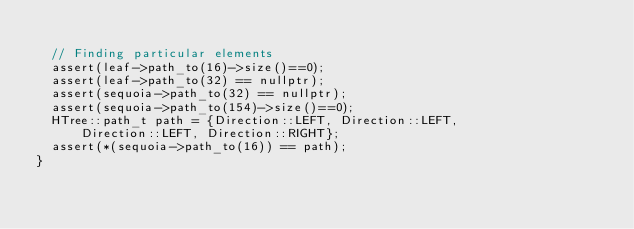Convert code to text. <code><loc_0><loc_0><loc_500><loc_500><_C++_>
  // Finding particular elements
  assert(leaf->path_to(16)->size()==0);
  assert(leaf->path_to(32) == nullptr);
  assert(sequoia->path_to(32) == nullptr);
  assert(sequoia->path_to(154)->size()==0);
  HTree::path_t path = {Direction::LEFT, Direction::LEFT,
      Direction::LEFT, Direction::RIGHT};
  assert(*(sequoia->path_to(16)) == path);
}
</code> 